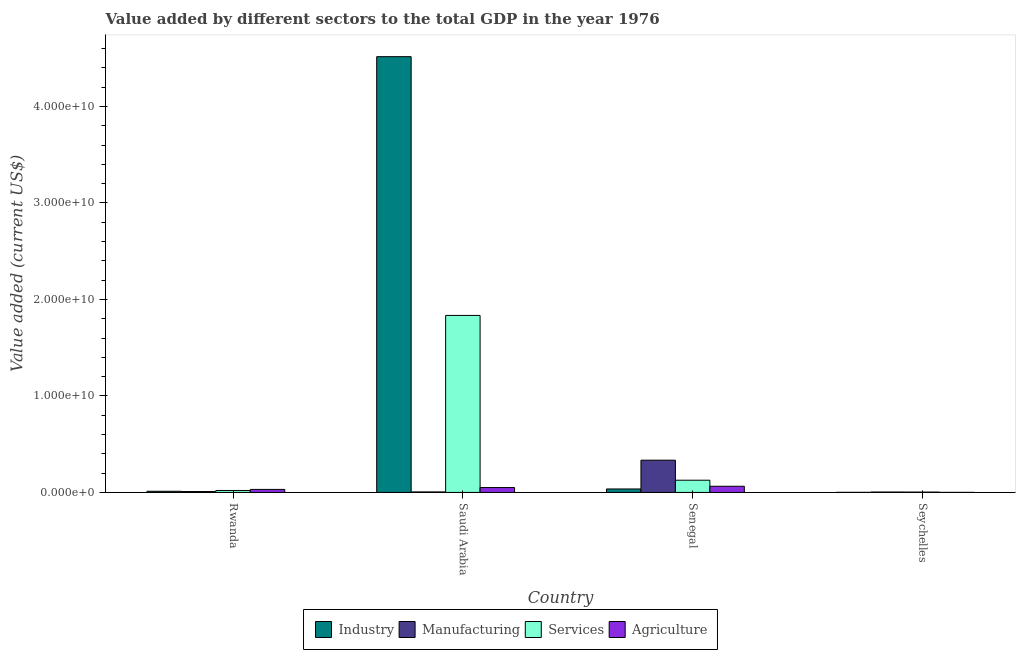How many different coloured bars are there?
Offer a terse response. 4. How many groups of bars are there?
Keep it short and to the point. 4. Are the number of bars on each tick of the X-axis equal?
Provide a succinct answer. Yes. What is the label of the 3rd group of bars from the left?
Keep it short and to the point. Senegal. What is the value added by industrial sector in Senegal?
Provide a short and direct response. 3.60e+08. Across all countries, what is the maximum value added by industrial sector?
Offer a very short reply. 4.52e+1. Across all countries, what is the minimum value added by industrial sector?
Your answer should be very brief. 7.99e+06. In which country was the value added by agricultural sector maximum?
Your answer should be very brief. Senegal. In which country was the value added by services sector minimum?
Offer a very short reply. Seychelles. What is the total value added by industrial sector in the graph?
Give a very brief answer. 4.56e+1. What is the difference between the value added by services sector in Saudi Arabia and that in Senegal?
Your answer should be compact. 1.71e+1. What is the difference between the value added by agricultural sector in Seychelles and the value added by services sector in Rwanda?
Keep it short and to the point. -1.99e+08. What is the average value added by services sector per country?
Give a very brief answer. 4.96e+09. What is the difference between the value added by agricultural sector and value added by industrial sector in Senegal?
Offer a very short reply. 2.81e+08. In how many countries, is the value added by manufacturing sector greater than 4000000000 US$?
Your answer should be compact. 0. What is the ratio of the value added by agricultural sector in Rwanda to that in Senegal?
Make the answer very short. 0.49. Is the value added by agricultural sector in Saudi Arabia less than that in Seychelles?
Your answer should be compact. No. Is the difference between the value added by services sector in Saudi Arabia and Senegal greater than the difference between the value added by industrial sector in Saudi Arabia and Senegal?
Keep it short and to the point. No. What is the difference between the highest and the second highest value added by services sector?
Provide a short and direct response. 1.71e+1. What is the difference between the highest and the lowest value added by agricultural sector?
Keep it short and to the point. 6.36e+08. In how many countries, is the value added by manufacturing sector greater than the average value added by manufacturing sector taken over all countries?
Make the answer very short. 1. Is the sum of the value added by industrial sector in Saudi Arabia and Senegal greater than the maximum value added by agricultural sector across all countries?
Your answer should be very brief. Yes. Is it the case that in every country, the sum of the value added by agricultural sector and value added by manufacturing sector is greater than the sum of value added by industrial sector and value added by services sector?
Offer a terse response. No. What does the 1st bar from the left in Senegal represents?
Your response must be concise. Industry. What does the 1st bar from the right in Seychelles represents?
Provide a succinct answer. Agriculture. Is it the case that in every country, the sum of the value added by industrial sector and value added by manufacturing sector is greater than the value added by services sector?
Your answer should be very brief. Yes. Are all the bars in the graph horizontal?
Your response must be concise. No. How many countries are there in the graph?
Your response must be concise. 4. What is the difference between two consecutive major ticks on the Y-axis?
Your response must be concise. 1.00e+1. Does the graph contain grids?
Your answer should be very brief. No. Where does the legend appear in the graph?
Your answer should be compact. Bottom center. What is the title of the graph?
Give a very brief answer. Value added by different sectors to the total GDP in the year 1976. What is the label or title of the Y-axis?
Provide a succinct answer. Value added (current US$). What is the Value added (current US$) in Industry in Rwanda?
Ensure brevity in your answer.  1.21e+08. What is the Value added (current US$) in Manufacturing in Rwanda?
Your answer should be compact. 9.06e+07. What is the Value added (current US$) in Services in Rwanda?
Your answer should be compact. 2.03e+08. What is the Value added (current US$) in Agriculture in Rwanda?
Offer a terse response. 3.14e+08. What is the Value added (current US$) of Industry in Saudi Arabia?
Provide a succinct answer. 4.52e+1. What is the Value added (current US$) of Manufacturing in Saudi Arabia?
Give a very brief answer. 5.29e+07. What is the Value added (current US$) of Services in Saudi Arabia?
Provide a succinct answer. 1.83e+1. What is the Value added (current US$) in Agriculture in Saudi Arabia?
Give a very brief answer. 5.07e+08. What is the Value added (current US$) of Industry in Senegal?
Ensure brevity in your answer.  3.60e+08. What is the Value added (current US$) of Manufacturing in Senegal?
Your answer should be very brief. 3.34e+09. What is the Value added (current US$) in Services in Senegal?
Your answer should be compact. 1.27e+09. What is the Value added (current US$) of Agriculture in Senegal?
Make the answer very short. 6.41e+08. What is the Value added (current US$) in Industry in Seychelles?
Ensure brevity in your answer.  7.99e+06. What is the Value added (current US$) in Manufacturing in Seychelles?
Offer a terse response. 4.31e+07. What is the Value added (current US$) in Services in Seychelles?
Provide a succinct answer. 3.65e+07. What is the Value added (current US$) of Agriculture in Seychelles?
Make the answer very short. 4.74e+06. Across all countries, what is the maximum Value added (current US$) in Industry?
Keep it short and to the point. 4.52e+1. Across all countries, what is the maximum Value added (current US$) in Manufacturing?
Your answer should be compact. 3.34e+09. Across all countries, what is the maximum Value added (current US$) of Services?
Give a very brief answer. 1.83e+1. Across all countries, what is the maximum Value added (current US$) of Agriculture?
Offer a terse response. 6.41e+08. Across all countries, what is the minimum Value added (current US$) in Industry?
Offer a terse response. 7.99e+06. Across all countries, what is the minimum Value added (current US$) in Manufacturing?
Give a very brief answer. 4.31e+07. Across all countries, what is the minimum Value added (current US$) of Services?
Your answer should be compact. 3.65e+07. Across all countries, what is the minimum Value added (current US$) in Agriculture?
Provide a short and direct response. 4.74e+06. What is the total Value added (current US$) in Industry in the graph?
Offer a terse response. 4.56e+1. What is the total Value added (current US$) of Manufacturing in the graph?
Give a very brief answer. 3.53e+09. What is the total Value added (current US$) in Services in the graph?
Provide a short and direct response. 1.98e+1. What is the total Value added (current US$) of Agriculture in the graph?
Make the answer very short. 1.47e+09. What is the difference between the Value added (current US$) of Industry in Rwanda and that in Saudi Arabia?
Your response must be concise. -4.50e+1. What is the difference between the Value added (current US$) of Manufacturing in Rwanda and that in Saudi Arabia?
Make the answer very short. 3.77e+07. What is the difference between the Value added (current US$) of Services in Rwanda and that in Saudi Arabia?
Give a very brief answer. -1.81e+1. What is the difference between the Value added (current US$) of Agriculture in Rwanda and that in Saudi Arabia?
Provide a succinct answer. -1.93e+08. What is the difference between the Value added (current US$) of Industry in Rwanda and that in Senegal?
Your response must be concise. -2.39e+08. What is the difference between the Value added (current US$) of Manufacturing in Rwanda and that in Senegal?
Offer a terse response. -3.25e+09. What is the difference between the Value added (current US$) of Services in Rwanda and that in Senegal?
Offer a very short reply. -1.06e+09. What is the difference between the Value added (current US$) in Agriculture in Rwanda and that in Senegal?
Offer a terse response. -3.27e+08. What is the difference between the Value added (current US$) of Industry in Rwanda and that in Seychelles?
Your response must be concise. 1.13e+08. What is the difference between the Value added (current US$) in Manufacturing in Rwanda and that in Seychelles?
Your answer should be compact. 4.75e+07. What is the difference between the Value added (current US$) in Services in Rwanda and that in Seychelles?
Your response must be concise. 1.67e+08. What is the difference between the Value added (current US$) in Agriculture in Rwanda and that in Seychelles?
Provide a short and direct response. 3.09e+08. What is the difference between the Value added (current US$) in Industry in Saudi Arabia and that in Senegal?
Keep it short and to the point. 4.48e+1. What is the difference between the Value added (current US$) in Manufacturing in Saudi Arabia and that in Senegal?
Give a very brief answer. -3.29e+09. What is the difference between the Value added (current US$) of Services in Saudi Arabia and that in Senegal?
Your response must be concise. 1.71e+1. What is the difference between the Value added (current US$) of Agriculture in Saudi Arabia and that in Senegal?
Offer a terse response. -1.34e+08. What is the difference between the Value added (current US$) of Industry in Saudi Arabia and that in Seychelles?
Provide a succinct answer. 4.51e+1. What is the difference between the Value added (current US$) of Manufacturing in Saudi Arabia and that in Seychelles?
Offer a very short reply. 9.79e+06. What is the difference between the Value added (current US$) in Services in Saudi Arabia and that in Seychelles?
Your answer should be compact. 1.83e+1. What is the difference between the Value added (current US$) in Agriculture in Saudi Arabia and that in Seychelles?
Your answer should be compact. 5.02e+08. What is the difference between the Value added (current US$) of Industry in Senegal and that in Seychelles?
Your response must be concise. 3.52e+08. What is the difference between the Value added (current US$) in Manufacturing in Senegal and that in Seychelles?
Give a very brief answer. 3.30e+09. What is the difference between the Value added (current US$) in Services in Senegal and that in Seychelles?
Give a very brief answer. 1.23e+09. What is the difference between the Value added (current US$) of Agriculture in Senegal and that in Seychelles?
Give a very brief answer. 6.36e+08. What is the difference between the Value added (current US$) in Industry in Rwanda and the Value added (current US$) in Manufacturing in Saudi Arabia?
Keep it short and to the point. 6.76e+07. What is the difference between the Value added (current US$) in Industry in Rwanda and the Value added (current US$) in Services in Saudi Arabia?
Provide a short and direct response. -1.82e+1. What is the difference between the Value added (current US$) of Industry in Rwanda and the Value added (current US$) of Agriculture in Saudi Arabia?
Provide a short and direct response. -3.86e+08. What is the difference between the Value added (current US$) of Manufacturing in Rwanda and the Value added (current US$) of Services in Saudi Arabia?
Offer a very short reply. -1.83e+1. What is the difference between the Value added (current US$) of Manufacturing in Rwanda and the Value added (current US$) of Agriculture in Saudi Arabia?
Provide a short and direct response. -4.16e+08. What is the difference between the Value added (current US$) in Services in Rwanda and the Value added (current US$) in Agriculture in Saudi Arabia?
Offer a very short reply. -3.03e+08. What is the difference between the Value added (current US$) in Industry in Rwanda and the Value added (current US$) in Manufacturing in Senegal?
Make the answer very short. -3.22e+09. What is the difference between the Value added (current US$) of Industry in Rwanda and the Value added (current US$) of Services in Senegal?
Give a very brief answer. -1.15e+09. What is the difference between the Value added (current US$) in Industry in Rwanda and the Value added (current US$) in Agriculture in Senegal?
Give a very brief answer. -5.20e+08. What is the difference between the Value added (current US$) in Manufacturing in Rwanda and the Value added (current US$) in Services in Senegal?
Provide a succinct answer. -1.18e+09. What is the difference between the Value added (current US$) in Manufacturing in Rwanda and the Value added (current US$) in Agriculture in Senegal?
Your response must be concise. -5.50e+08. What is the difference between the Value added (current US$) in Services in Rwanda and the Value added (current US$) in Agriculture in Senegal?
Your response must be concise. -4.37e+08. What is the difference between the Value added (current US$) in Industry in Rwanda and the Value added (current US$) in Manufacturing in Seychelles?
Offer a very short reply. 7.74e+07. What is the difference between the Value added (current US$) of Industry in Rwanda and the Value added (current US$) of Services in Seychelles?
Your response must be concise. 8.40e+07. What is the difference between the Value added (current US$) in Industry in Rwanda and the Value added (current US$) in Agriculture in Seychelles?
Give a very brief answer. 1.16e+08. What is the difference between the Value added (current US$) in Manufacturing in Rwanda and the Value added (current US$) in Services in Seychelles?
Your answer should be very brief. 5.41e+07. What is the difference between the Value added (current US$) of Manufacturing in Rwanda and the Value added (current US$) of Agriculture in Seychelles?
Your answer should be compact. 8.59e+07. What is the difference between the Value added (current US$) in Services in Rwanda and the Value added (current US$) in Agriculture in Seychelles?
Ensure brevity in your answer.  1.99e+08. What is the difference between the Value added (current US$) of Industry in Saudi Arabia and the Value added (current US$) of Manufacturing in Senegal?
Give a very brief answer. 4.18e+1. What is the difference between the Value added (current US$) of Industry in Saudi Arabia and the Value added (current US$) of Services in Senegal?
Your answer should be compact. 4.39e+1. What is the difference between the Value added (current US$) of Industry in Saudi Arabia and the Value added (current US$) of Agriculture in Senegal?
Provide a short and direct response. 4.45e+1. What is the difference between the Value added (current US$) of Manufacturing in Saudi Arabia and the Value added (current US$) of Services in Senegal?
Ensure brevity in your answer.  -1.21e+09. What is the difference between the Value added (current US$) in Manufacturing in Saudi Arabia and the Value added (current US$) in Agriculture in Senegal?
Keep it short and to the point. -5.88e+08. What is the difference between the Value added (current US$) of Services in Saudi Arabia and the Value added (current US$) of Agriculture in Senegal?
Make the answer very short. 1.77e+1. What is the difference between the Value added (current US$) of Industry in Saudi Arabia and the Value added (current US$) of Manufacturing in Seychelles?
Provide a succinct answer. 4.51e+1. What is the difference between the Value added (current US$) in Industry in Saudi Arabia and the Value added (current US$) in Services in Seychelles?
Keep it short and to the point. 4.51e+1. What is the difference between the Value added (current US$) in Industry in Saudi Arabia and the Value added (current US$) in Agriculture in Seychelles?
Provide a short and direct response. 4.52e+1. What is the difference between the Value added (current US$) in Manufacturing in Saudi Arabia and the Value added (current US$) in Services in Seychelles?
Your answer should be compact. 1.64e+07. What is the difference between the Value added (current US$) of Manufacturing in Saudi Arabia and the Value added (current US$) of Agriculture in Seychelles?
Your answer should be very brief. 4.82e+07. What is the difference between the Value added (current US$) in Services in Saudi Arabia and the Value added (current US$) in Agriculture in Seychelles?
Provide a succinct answer. 1.83e+1. What is the difference between the Value added (current US$) of Industry in Senegal and the Value added (current US$) of Manufacturing in Seychelles?
Offer a terse response. 3.16e+08. What is the difference between the Value added (current US$) of Industry in Senegal and the Value added (current US$) of Services in Seychelles?
Your response must be concise. 3.23e+08. What is the difference between the Value added (current US$) of Industry in Senegal and the Value added (current US$) of Agriculture in Seychelles?
Keep it short and to the point. 3.55e+08. What is the difference between the Value added (current US$) in Manufacturing in Senegal and the Value added (current US$) in Services in Seychelles?
Offer a terse response. 3.31e+09. What is the difference between the Value added (current US$) of Manufacturing in Senegal and the Value added (current US$) of Agriculture in Seychelles?
Your answer should be very brief. 3.34e+09. What is the difference between the Value added (current US$) of Services in Senegal and the Value added (current US$) of Agriculture in Seychelles?
Provide a succinct answer. 1.26e+09. What is the average Value added (current US$) in Industry per country?
Give a very brief answer. 1.14e+1. What is the average Value added (current US$) of Manufacturing per country?
Your response must be concise. 8.82e+08. What is the average Value added (current US$) in Services per country?
Ensure brevity in your answer.  4.96e+09. What is the average Value added (current US$) in Agriculture per country?
Provide a succinct answer. 3.66e+08. What is the difference between the Value added (current US$) in Industry and Value added (current US$) in Manufacturing in Rwanda?
Your answer should be compact. 2.99e+07. What is the difference between the Value added (current US$) in Industry and Value added (current US$) in Services in Rwanda?
Keep it short and to the point. -8.29e+07. What is the difference between the Value added (current US$) of Industry and Value added (current US$) of Agriculture in Rwanda?
Offer a very short reply. -1.93e+08. What is the difference between the Value added (current US$) of Manufacturing and Value added (current US$) of Services in Rwanda?
Ensure brevity in your answer.  -1.13e+08. What is the difference between the Value added (current US$) of Manufacturing and Value added (current US$) of Agriculture in Rwanda?
Make the answer very short. -2.23e+08. What is the difference between the Value added (current US$) of Services and Value added (current US$) of Agriculture in Rwanda?
Your response must be concise. -1.11e+08. What is the difference between the Value added (current US$) in Industry and Value added (current US$) in Manufacturing in Saudi Arabia?
Your answer should be compact. 4.51e+1. What is the difference between the Value added (current US$) in Industry and Value added (current US$) in Services in Saudi Arabia?
Provide a short and direct response. 2.68e+1. What is the difference between the Value added (current US$) in Industry and Value added (current US$) in Agriculture in Saudi Arabia?
Your answer should be very brief. 4.47e+1. What is the difference between the Value added (current US$) of Manufacturing and Value added (current US$) of Services in Saudi Arabia?
Offer a very short reply. -1.83e+1. What is the difference between the Value added (current US$) in Manufacturing and Value added (current US$) in Agriculture in Saudi Arabia?
Ensure brevity in your answer.  -4.54e+08. What is the difference between the Value added (current US$) in Services and Value added (current US$) in Agriculture in Saudi Arabia?
Offer a very short reply. 1.78e+1. What is the difference between the Value added (current US$) of Industry and Value added (current US$) of Manufacturing in Senegal?
Make the answer very short. -2.98e+09. What is the difference between the Value added (current US$) in Industry and Value added (current US$) in Services in Senegal?
Ensure brevity in your answer.  -9.07e+08. What is the difference between the Value added (current US$) of Industry and Value added (current US$) of Agriculture in Senegal?
Give a very brief answer. -2.81e+08. What is the difference between the Value added (current US$) of Manufacturing and Value added (current US$) of Services in Senegal?
Offer a terse response. 2.08e+09. What is the difference between the Value added (current US$) of Manufacturing and Value added (current US$) of Agriculture in Senegal?
Your answer should be compact. 2.70e+09. What is the difference between the Value added (current US$) of Services and Value added (current US$) of Agriculture in Senegal?
Make the answer very short. 6.26e+08. What is the difference between the Value added (current US$) of Industry and Value added (current US$) of Manufacturing in Seychelles?
Keep it short and to the point. -3.51e+07. What is the difference between the Value added (current US$) in Industry and Value added (current US$) in Services in Seychelles?
Your answer should be very brief. -2.86e+07. What is the difference between the Value added (current US$) of Industry and Value added (current US$) of Agriculture in Seychelles?
Provide a succinct answer. 3.25e+06. What is the difference between the Value added (current US$) of Manufacturing and Value added (current US$) of Services in Seychelles?
Your answer should be very brief. 6.56e+06. What is the difference between the Value added (current US$) of Manufacturing and Value added (current US$) of Agriculture in Seychelles?
Ensure brevity in your answer.  3.84e+07. What is the difference between the Value added (current US$) of Services and Value added (current US$) of Agriculture in Seychelles?
Your answer should be compact. 3.18e+07. What is the ratio of the Value added (current US$) in Industry in Rwanda to that in Saudi Arabia?
Keep it short and to the point. 0. What is the ratio of the Value added (current US$) of Manufacturing in Rwanda to that in Saudi Arabia?
Keep it short and to the point. 1.71. What is the ratio of the Value added (current US$) in Services in Rwanda to that in Saudi Arabia?
Offer a terse response. 0.01. What is the ratio of the Value added (current US$) of Agriculture in Rwanda to that in Saudi Arabia?
Provide a short and direct response. 0.62. What is the ratio of the Value added (current US$) in Industry in Rwanda to that in Senegal?
Offer a terse response. 0.34. What is the ratio of the Value added (current US$) in Manufacturing in Rwanda to that in Senegal?
Make the answer very short. 0.03. What is the ratio of the Value added (current US$) of Services in Rwanda to that in Senegal?
Provide a succinct answer. 0.16. What is the ratio of the Value added (current US$) of Agriculture in Rwanda to that in Senegal?
Provide a succinct answer. 0.49. What is the ratio of the Value added (current US$) of Industry in Rwanda to that in Seychelles?
Your answer should be compact. 15.08. What is the ratio of the Value added (current US$) in Manufacturing in Rwanda to that in Seychelles?
Your response must be concise. 2.1. What is the ratio of the Value added (current US$) of Services in Rwanda to that in Seychelles?
Provide a short and direct response. 5.56. What is the ratio of the Value added (current US$) in Agriculture in Rwanda to that in Seychelles?
Ensure brevity in your answer.  66.2. What is the ratio of the Value added (current US$) of Industry in Saudi Arabia to that in Senegal?
Your answer should be compact. 125.59. What is the ratio of the Value added (current US$) in Manufacturing in Saudi Arabia to that in Senegal?
Your response must be concise. 0.02. What is the ratio of the Value added (current US$) in Services in Saudi Arabia to that in Senegal?
Provide a succinct answer. 14.48. What is the ratio of the Value added (current US$) of Agriculture in Saudi Arabia to that in Senegal?
Offer a terse response. 0.79. What is the ratio of the Value added (current US$) in Industry in Saudi Arabia to that in Seychelles?
Your response must be concise. 5651.99. What is the ratio of the Value added (current US$) of Manufacturing in Saudi Arabia to that in Seychelles?
Provide a succinct answer. 1.23. What is the ratio of the Value added (current US$) in Services in Saudi Arabia to that in Seychelles?
Offer a terse response. 501.86. What is the ratio of the Value added (current US$) of Agriculture in Saudi Arabia to that in Seychelles?
Offer a very short reply. 106.82. What is the ratio of the Value added (current US$) of Industry in Senegal to that in Seychelles?
Ensure brevity in your answer.  45. What is the ratio of the Value added (current US$) of Manufacturing in Senegal to that in Seychelles?
Your response must be concise. 77.56. What is the ratio of the Value added (current US$) in Services in Senegal to that in Seychelles?
Your answer should be compact. 34.66. What is the ratio of the Value added (current US$) of Agriculture in Senegal to that in Seychelles?
Keep it short and to the point. 135.09. What is the difference between the highest and the second highest Value added (current US$) of Industry?
Make the answer very short. 4.48e+1. What is the difference between the highest and the second highest Value added (current US$) in Manufacturing?
Provide a short and direct response. 3.25e+09. What is the difference between the highest and the second highest Value added (current US$) of Services?
Your answer should be compact. 1.71e+1. What is the difference between the highest and the second highest Value added (current US$) in Agriculture?
Keep it short and to the point. 1.34e+08. What is the difference between the highest and the lowest Value added (current US$) of Industry?
Offer a very short reply. 4.51e+1. What is the difference between the highest and the lowest Value added (current US$) of Manufacturing?
Provide a succinct answer. 3.30e+09. What is the difference between the highest and the lowest Value added (current US$) in Services?
Provide a succinct answer. 1.83e+1. What is the difference between the highest and the lowest Value added (current US$) in Agriculture?
Your answer should be compact. 6.36e+08. 